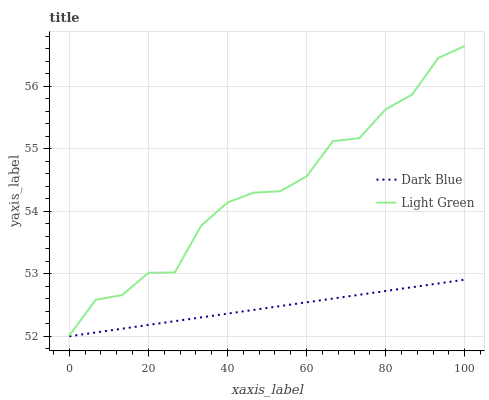Does Dark Blue have the minimum area under the curve?
Answer yes or no. Yes. Does Light Green have the maximum area under the curve?
Answer yes or no. Yes. Does Light Green have the minimum area under the curve?
Answer yes or no. No. Is Dark Blue the smoothest?
Answer yes or no. Yes. Is Light Green the roughest?
Answer yes or no. Yes. Is Light Green the smoothest?
Answer yes or no. No. Does Light Green have the lowest value?
Answer yes or no. No. Does Light Green have the highest value?
Answer yes or no. Yes. Is Dark Blue less than Light Green?
Answer yes or no. Yes. Is Light Green greater than Dark Blue?
Answer yes or no. Yes. Does Dark Blue intersect Light Green?
Answer yes or no. No. 